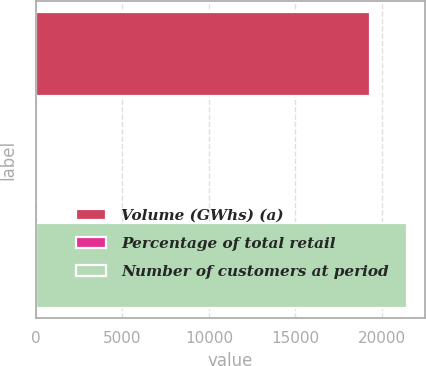Convert chart. <chart><loc_0><loc_0><loc_500><loc_500><bar_chart><fcel>Volume (GWhs) (a)<fcel>Percentage of total retail<fcel>Number of customers at period<nl><fcel>19310<fcel>21<fcel>21435.5<nl></chart> 